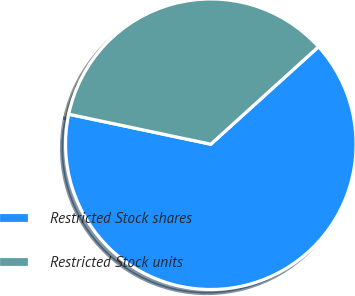Convert chart to OTSL. <chart><loc_0><loc_0><loc_500><loc_500><pie_chart><fcel>Restricted Stock shares<fcel>Restricted Stock units<nl><fcel>65.02%<fcel>34.98%<nl></chart> 